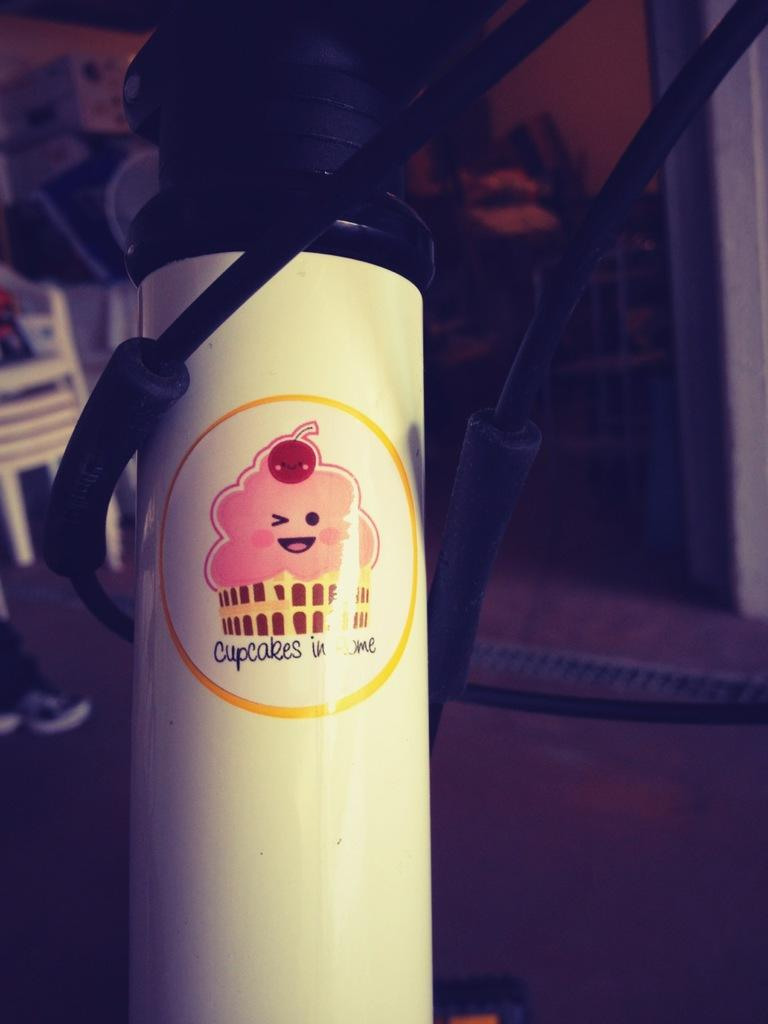<image>
Create a compact narrative representing the image presented. A white bottle has a label which reads Cupcakes in Rome. 